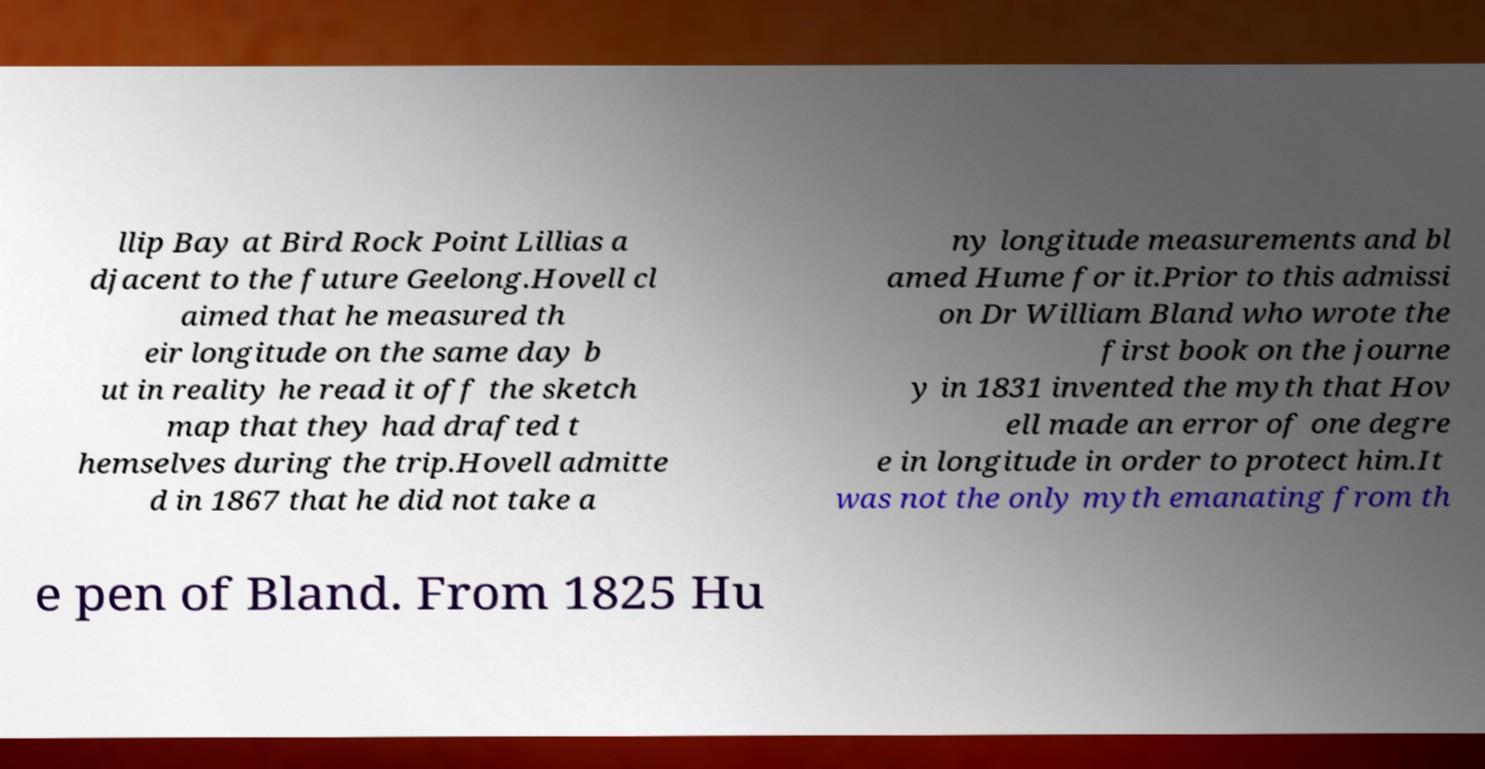For documentation purposes, I need the text within this image transcribed. Could you provide that? llip Bay at Bird Rock Point Lillias a djacent to the future Geelong.Hovell cl aimed that he measured th eir longitude on the same day b ut in reality he read it off the sketch map that they had drafted t hemselves during the trip.Hovell admitte d in 1867 that he did not take a ny longitude measurements and bl amed Hume for it.Prior to this admissi on Dr William Bland who wrote the first book on the journe y in 1831 invented the myth that Hov ell made an error of one degre e in longitude in order to protect him.It was not the only myth emanating from th e pen of Bland. From 1825 Hu 